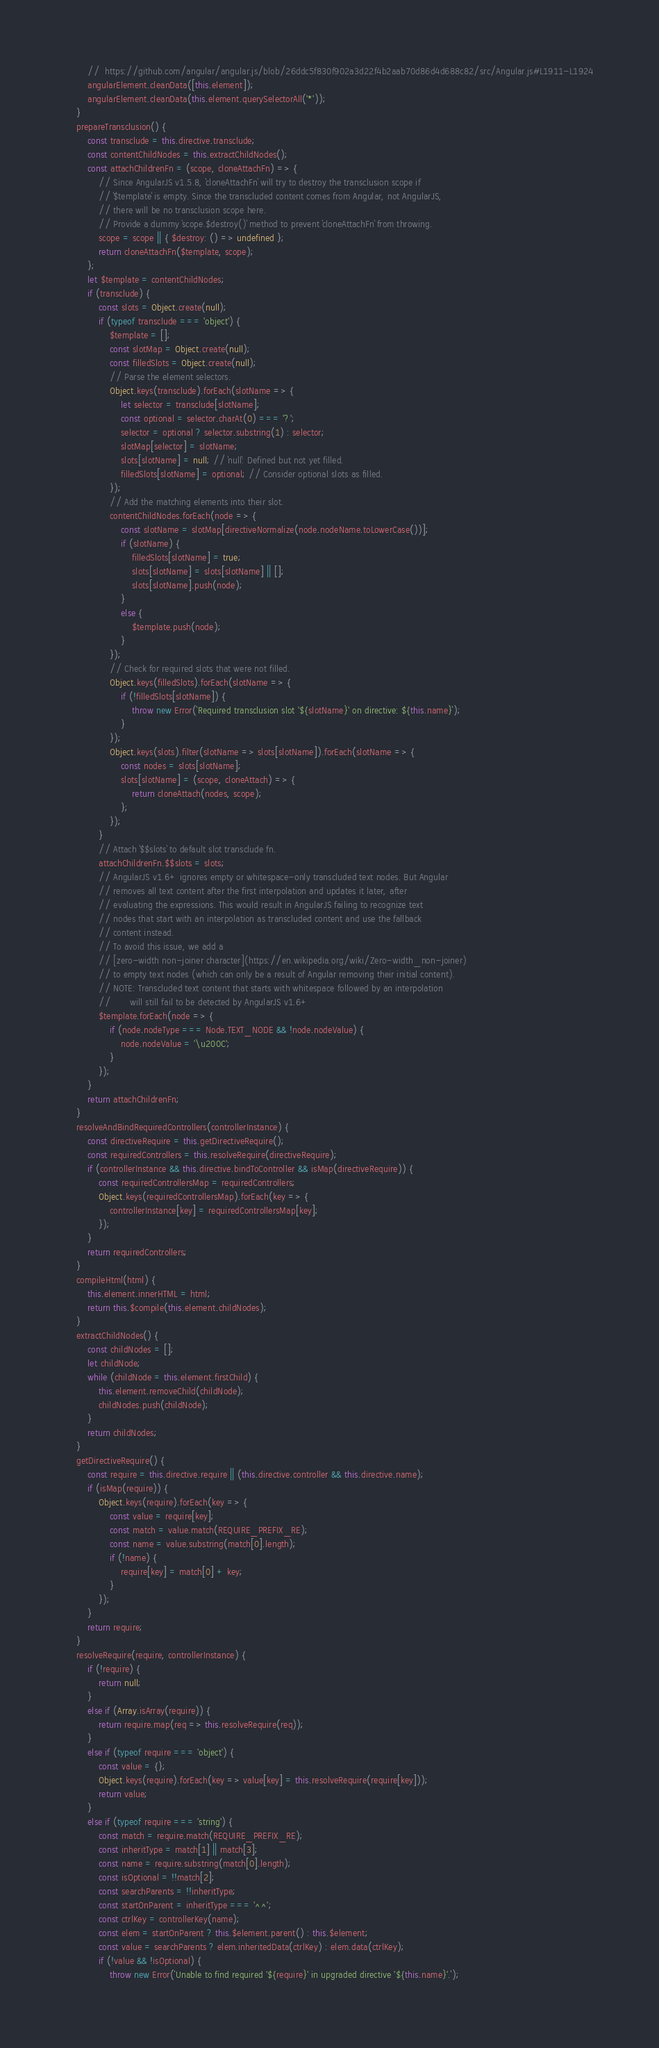Convert code to text. <code><loc_0><loc_0><loc_500><loc_500><_JavaScript_>        //  https://github.com/angular/angular.js/blob/26ddc5f830f902a3d22f4b2aab70d86d4d688c82/src/Angular.js#L1911-L1924
        angularElement.cleanData([this.element]);
        angularElement.cleanData(this.element.querySelectorAll('*'));
    }
    prepareTransclusion() {
        const transclude = this.directive.transclude;
        const contentChildNodes = this.extractChildNodes();
        const attachChildrenFn = (scope, cloneAttachFn) => {
            // Since AngularJS v1.5.8, `cloneAttachFn` will try to destroy the transclusion scope if
            // `$template` is empty. Since the transcluded content comes from Angular, not AngularJS,
            // there will be no transclusion scope here.
            // Provide a dummy `scope.$destroy()` method to prevent `cloneAttachFn` from throwing.
            scope = scope || { $destroy: () => undefined };
            return cloneAttachFn($template, scope);
        };
        let $template = contentChildNodes;
        if (transclude) {
            const slots = Object.create(null);
            if (typeof transclude === 'object') {
                $template = [];
                const slotMap = Object.create(null);
                const filledSlots = Object.create(null);
                // Parse the element selectors.
                Object.keys(transclude).forEach(slotName => {
                    let selector = transclude[slotName];
                    const optional = selector.charAt(0) === '?';
                    selector = optional ? selector.substring(1) : selector;
                    slotMap[selector] = slotName;
                    slots[slotName] = null; // `null`: Defined but not yet filled.
                    filledSlots[slotName] = optional; // Consider optional slots as filled.
                });
                // Add the matching elements into their slot.
                contentChildNodes.forEach(node => {
                    const slotName = slotMap[directiveNormalize(node.nodeName.toLowerCase())];
                    if (slotName) {
                        filledSlots[slotName] = true;
                        slots[slotName] = slots[slotName] || [];
                        slots[slotName].push(node);
                    }
                    else {
                        $template.push(node);
                    }
                });
                // Check for required slots that were not filled.
                Object.keys(filledSlots).forEach(slotName => {
                    if (!filledSlots[slotName]) {
                        throw new Error(`Required transclusion slot '${slotName}' on directive: ${this.name}`);
                    }
                });
                Object.keys(slots).filter(slotName => slots[slotName]).forEach(slotName => {
                    const nodes = slots[slotName];
                    slots[slotName] = (scope, cloneAttach) => {
                        return cloneAttach(nodes, scope);
                    };
                });
            }
            // Attach `$$slots` to default slot transclude fn.
            attachChildrenFn.$$slots = slots;
            // AngularJS v1.6+ ignores empty or whitespace-only transcluded text nodes. But Angular
            // removes all text content after the first interpolation and updates it later, after
            // evaluating the expressions. This would result in AngularJS failing to recognize text
            // nodes that start with an interpolation as transcluded content and use the fallback
            // content instead.
            // To avoid this issue, we add a
            // [zero-width non-joiner character](https://en.wikipedia.org/wiki/Zero-width_non-joiner)
            // to empty text nodes (which can only be a result of Angular removing their initial content).
            // NOTE: Transcluded text content that starts with whitespace followed by an interpolation
            //       will still fail to be detected by AngularJS v1.6+
            $template.forEach(node => {
                if (node.nodeType === Node.TEXT_NODE && !node.nodeValue) {
                    node.nodeValue = '\u200C';
                }
            });
        }
        return attachChildrenFn;
    }
    resolveAndBindRequiredControllers(controllerInstance) {
        const directiveRequire = this.getDirectiveRequire();
        const requiredControllers = this.resolveRequire(directiveRequire);
        if (controllerInstance && this.directive.bindToController && isMap(directiveRequire)) {
            const requiredControllersMap = requiredControllers;
            Object.keys(requiredControllersMap).forEach(key => {
                controllerInstance[key] = requiredControllersMap[key];
            });
        }
        return requiredControllers;
    }
    compileHtml(html) {
        this.element.innerHTML = html;
        return this.$compile(this.element.childNodes);
    }
    extractChildNodes() {
        const childNodes = [];
        let childNode;
        while (childNode = this.element.firstChild) {
            this.element.removeChild(childNode);
            childNodes.push(childNode);
        }
        return childNodes;
    }
    getDirectiveRequire() {
        const require = this.directive.require || (this.directive.controller && this.directive.name);
        if (isMap(require)) {
            Object.keys(require).forEach(key => {
                const value = require[key];
                const match = value.match(REQUIRE_PREFIX_RE);
                const name = value.substring(match[0].length);
                if (!name) {
                    require[key] = match[0] + key;
                }
            });
        }
        return require;
    }
    resolveRequire(require, controllerInstance) {
        if (!require) {
            return null;
        }
        else if (Array.isArray(require)) {
            return require.map(req => this.resolveRequire(req));
        }
        else if (typeof require === 'object') {
            const value = {};
            Object.keys(require).forEach(key => value[key] = this.resolveRequire(require[key]));
            return value;
        }
        else if (typeof require === 'string') {
            const match = require.match(REQUIRE_PREFIX_RE);
            const inheritType = match[1] || match[3];
            const name = require.substring(match[0].length);
            const isOptional = !!match[2];
            const searchParents = !!inheritType;
            const startOnParent = inheritType === '^^';
            const ctrlKey = controllerKey(name);
            const elem = startOnParent ? this.$element.parent() : this.$element;
            const value = searchParents ? elem.inheritedData(ctrlKey) : elem.data(ctrlKey);
            if (!value && !isOptional) {
                throw new Error(`Unable to find required '${require}' in upgraded directive '${this.name}'.`);</code> 